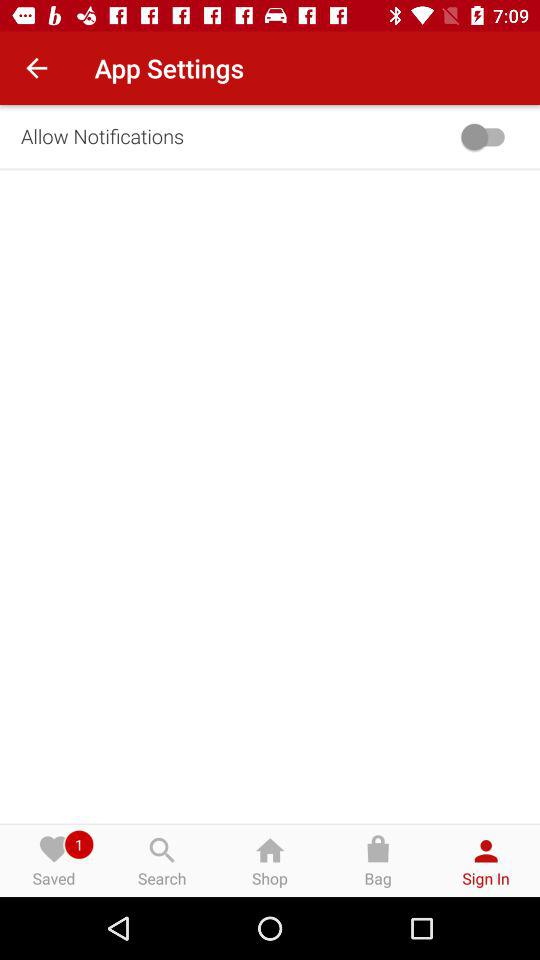How many items do I have saved?
Answer the question using a single word or phrase. 1 